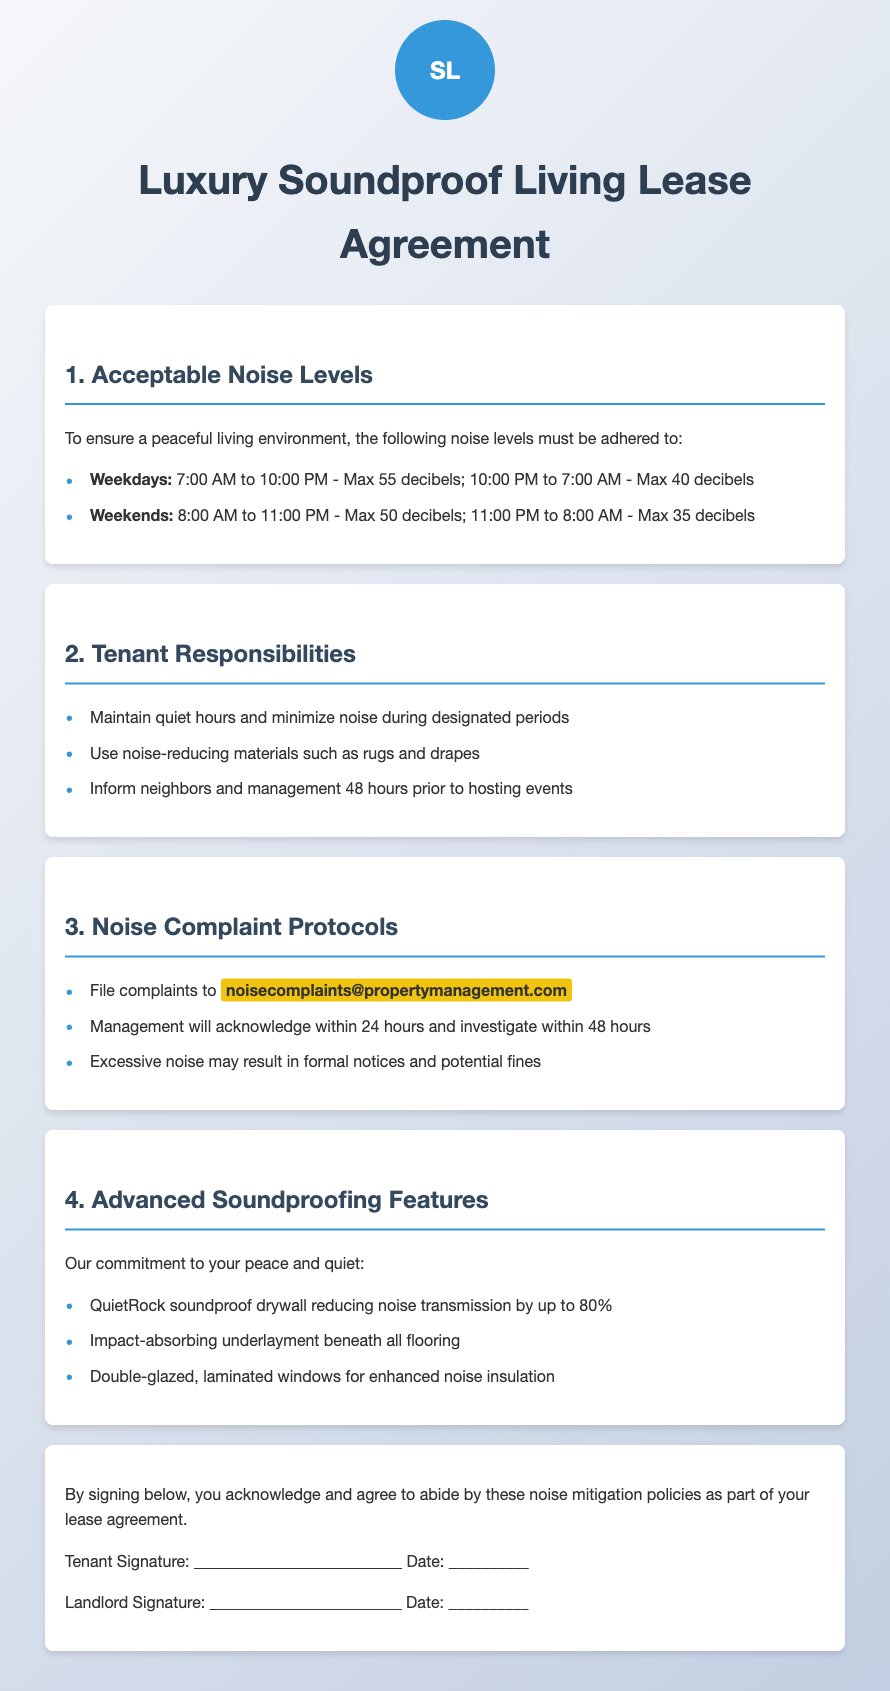What are the acceptable noise levels on weekdays? Acceptable noise levels are specified for weekdays, which are 55 decibels from 7:00 AM to 10:00 PM and 40 decibels from 10:00 PM to 7:00 AM.
Answer: 55 decibels; 40 decibels What are the quiet hours during weekends? The document specifies the maximum noise levels on weekends, which are 50 decibels from 8:00 AM to 11:00 PM and 35 decibels from 11:00 PM to 8:00 AM.
Answer: 50 decibels; 35 decibels What materials should tenants use to minimize noise? The document lists tenant responsibilities, including the use of noise-reducing materials such as rugs and drapes.
Answer: Rugs and drapes How long in advance must tenants inform management before hosting events? The policy outlines the tenant's responsibility to inform management 48 hours prior to hosting events.
Answer: 48 hours What is the email address for filing noise complaints? The document specifies the email address for noise complaints, which is mentioned in the protocol section.
Answer: noisecomplaints@propertymanagement.com What noise insulation feature reduces noise transmission by up to 80%? The features are highlighted in the soundproofing section, specifically QuietRock soundproof drywall.
Answer: QuietRock soundproof drywall Within how many hours will management investigate a noise complaint? According to the document, management will investigate a noise complaint within 48 hours.
Answer: 48 hours What is the start time for noise levels of 35 decibels on weekends? The document indicates that the noise level of 35 decibels applies starting from 11:00 PM on weekends.
Answer: 11:00 PM What may excessive noise result in? The document states that excessive noise may result in formal notices and potential fines.
Answer: Formal notices and fines 